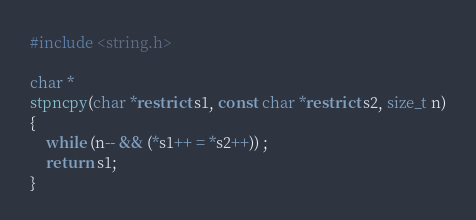Convert code to text. <code><loc_0><loc_0><loc_500><loc_500><_C_>#include <string.h>

char *
stpncpy(char *restrict s1, const char *restrict s2, size_t n)
{
	while (n-- && (*s1++ = *s2++)) ;
	return s1;
}
</code> 